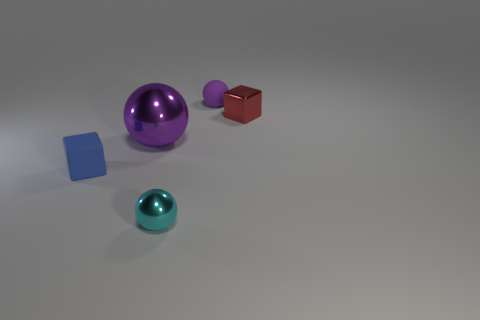Subtract all small balls. How many balls are left? 1 Subtract all red blocks. How many purple spheres are left? 2 Add 3 large purple spheres. How many objects exist? 8 Subtract all spheres. How many objects are left? 2 Add 3 big purple spheres. How many big purple spheres are left? 4 Add 3 tiny metallic objects. How many tiny metallic objects exist? 5 Subtract 0 brown cylinders. How many objects are left? 5 Subtract all green cubes. Subtract all purple cylinders. How many cubes are left? 2 Subtract all cyan metallic things. Subtract all purple metallic spheres. How many objects are left? 3 